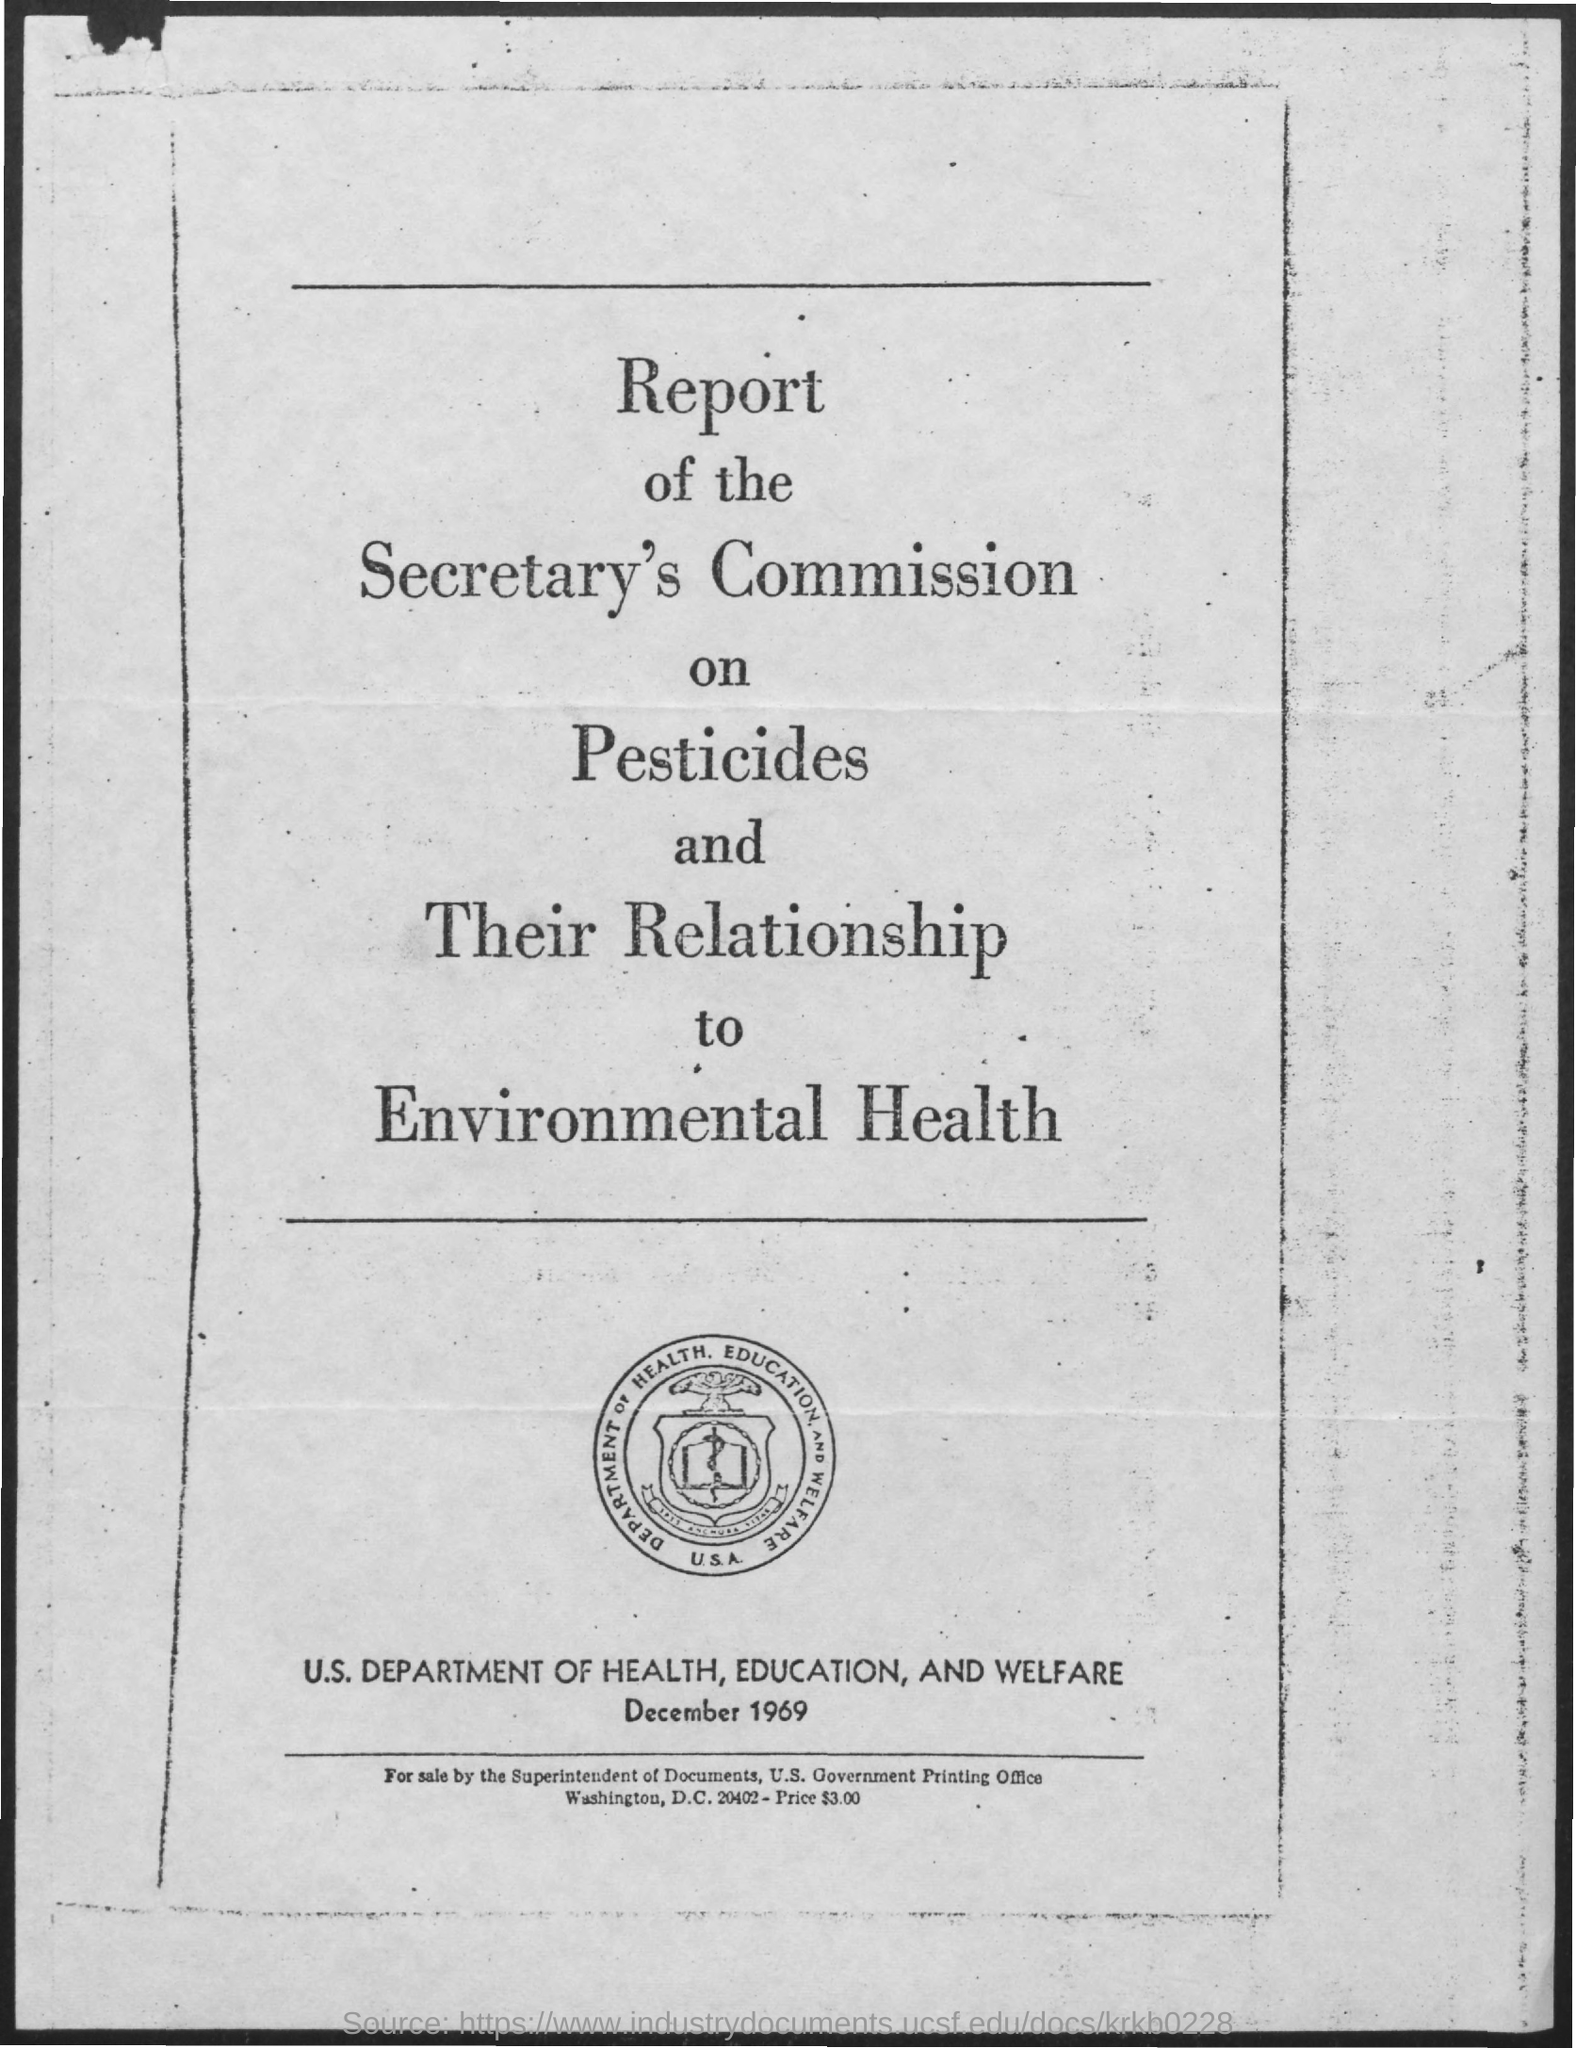For sale by whom?
Provide a short and direct response. The superintendent of documents, u.s. government printing office. What is the date on the document?
Keep it short and to the point. December 1969. 